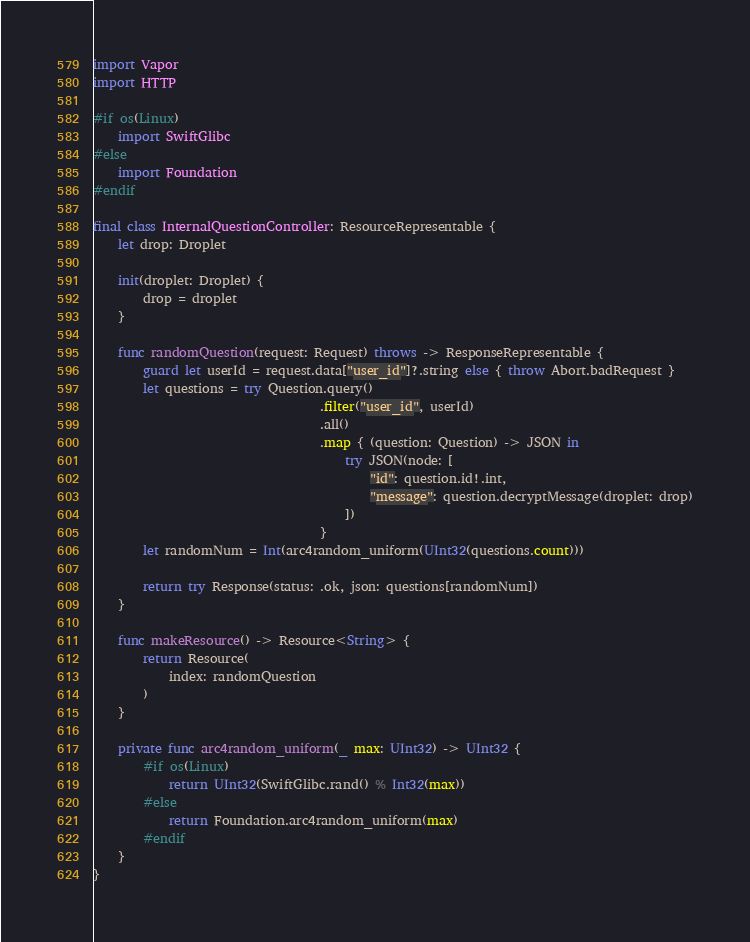<code> <loc_0><loc_0><loc_500><loc_500><_Swift_>import Vapor
import HTTP

#if os(Linux)
    import SwiftGlibc
#else
    import Foundation
#endif

final class InternalQuestionController: ResourceRepresentable {
    let drop: Droplet

    init(droplet: Droplet) {
        drop = droplet
    }

    func randomQuestion(request: Request) throws -> ResponseRepresentable {
        guard let userId = request.data["user_id"]?.string else { throw Abort.badRequest }
        let questions = try Question.query()
                                    .filter("user_id", userId)
                                    .all()
                                    .map { (question: Question) -> JSON in
                                        try JSON(node: [
                                            "id": question.id!.int,
                                            "message": question.decryptMessage(droplet: drop)
                                        ])
                                    }
        let randomNum = Int(arc4random_uniform(UInt32(questions.count)))

        return try Response(status: .ok, json: questions[randomNum])
    }

    func makeResource() -> Resource<String> {
        return Resource(
            index: randomQuestion
        )
    }

    private func arc4random_uniform(_ max: UInt32) -> UInt32 {
        #if os(Linux)
            return UInt32(SwiftGlibc.rand() % Int32(max))
        #else
            return Foundation.arc4random_uniform(max)
        #endif
    }
}</code> 